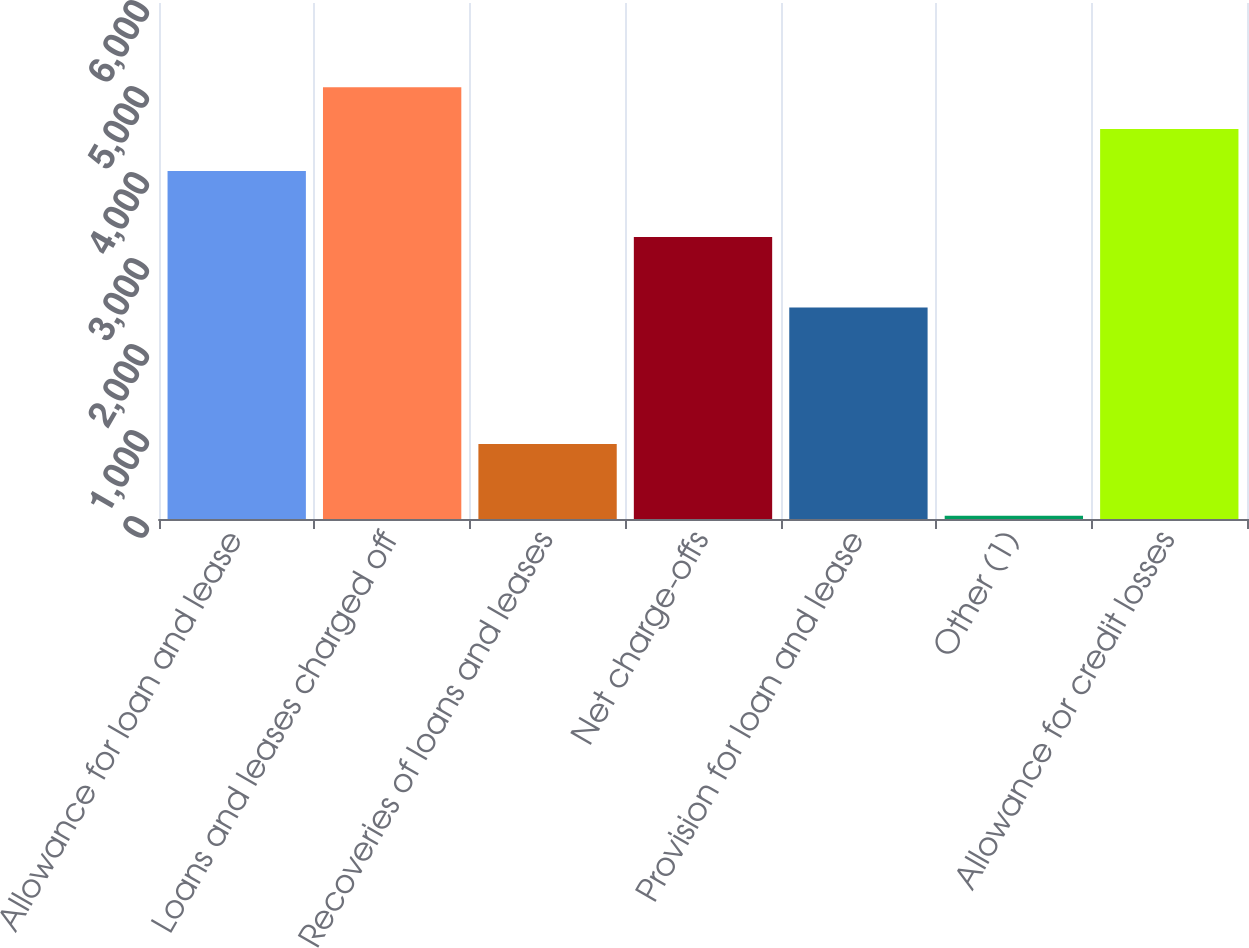Convert chart to OTSL. <chart><loc_0><loc_0><loc_500><loc_500><bar_chart><fcel>Allowance for loan and lease<fcel>Loans and leases charged off<fcel>Recoveries of loans and leases<fcel>Net charge-offs<fcel>Provision for loan and lease<fcel>Other (1)<fcel>Allowance for credit losses<nl><fcel>4047<fcel>5020.4<fcel>871<fcel>3278<fcel>2458<fcel>38<fcel>4533.7<nl></chart> 